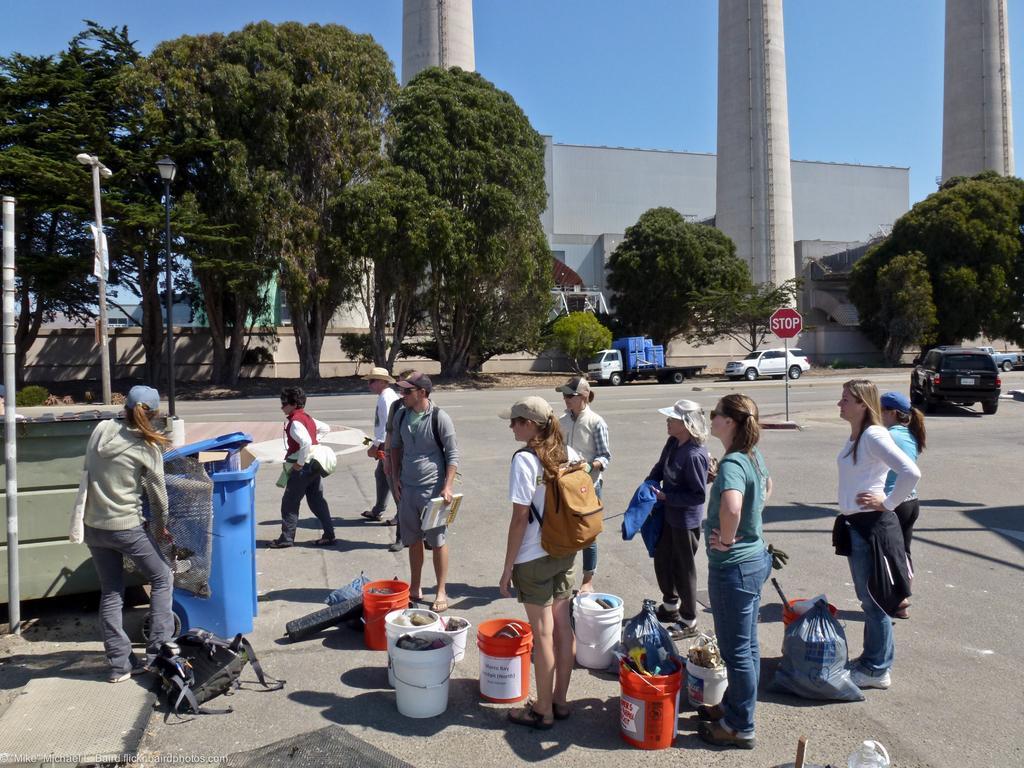Please provide a concise description of this image. In this picture we can see some people standing, buckets, bags, vehicles on the road, poles, lights, trees, building, signboard, some objects and in the background we can see the sky. 